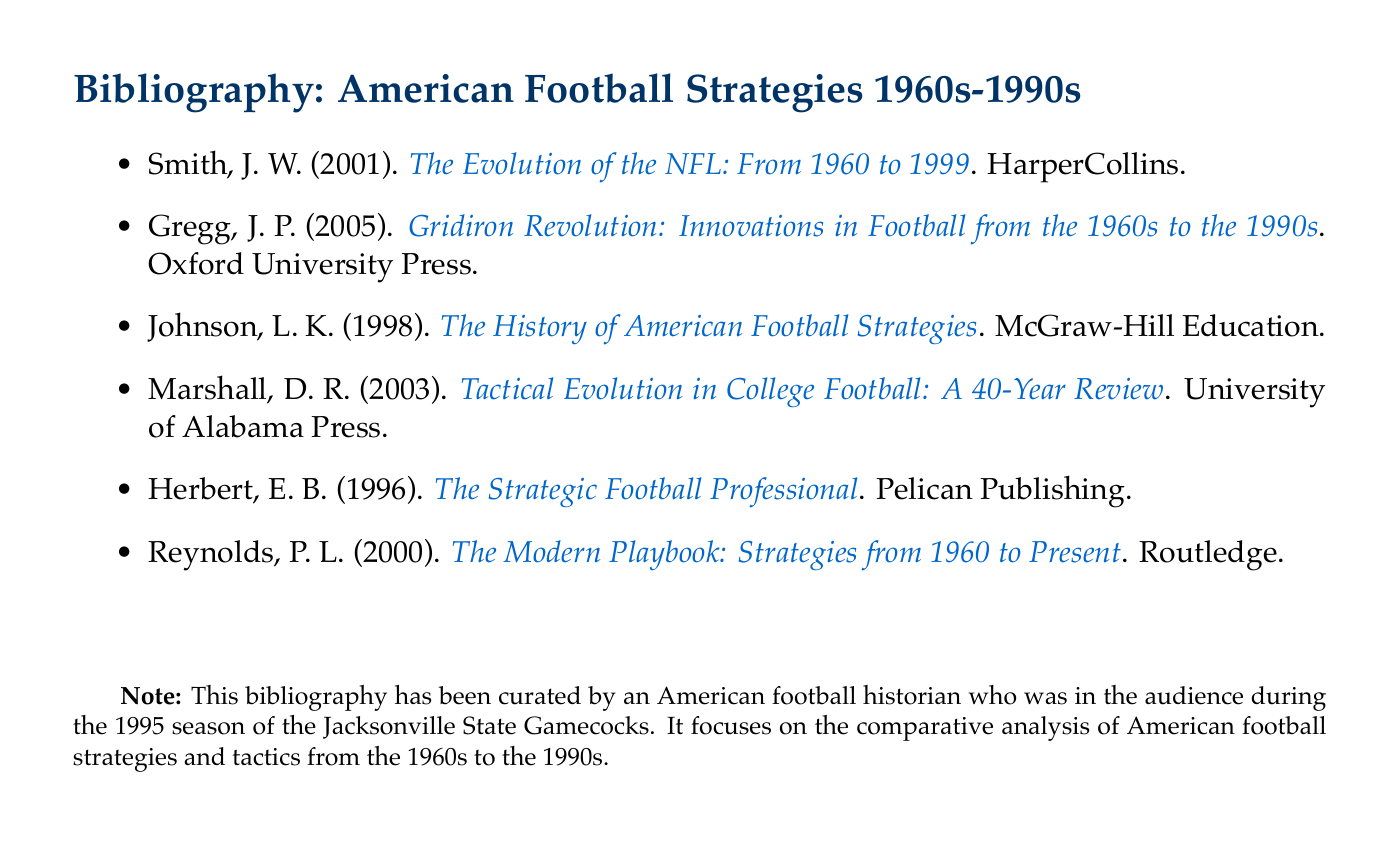What is the title of the first item in the bibliography? The title is listed in the first bullet point of the bibliography.
Answer: The Evolution of the NFL: From 1960 to 1999 Who authored "Gridiron Revolution: Innovations in Football from the 1960s to the 1990s"? The author can be found in the second item of the bibliography.
Answer: J. P. Gregg Which publication year is associated with "The History of American Football Strategies"? The publication year is listed next to the author in the bibliography.
Answer: 1998 How many total items are in the bibliography? Count the number of items listed under the bibliography section.
Answer: Six Which university published the book titled "Tactical Evolution in College Football: A 40-Year Review"? The publisher is mentioned in the citation of the corresponding item.
Answer: University of Alabama Press What is the focus of the bibliography? The focus is indicated in the note at the bottom of the document.
Answer: Comparative analysis of American football strategies and tactics What color is used for the title of each bibliography entry? The color used is highlighted in the title format section of the document.
Answer: Blue 